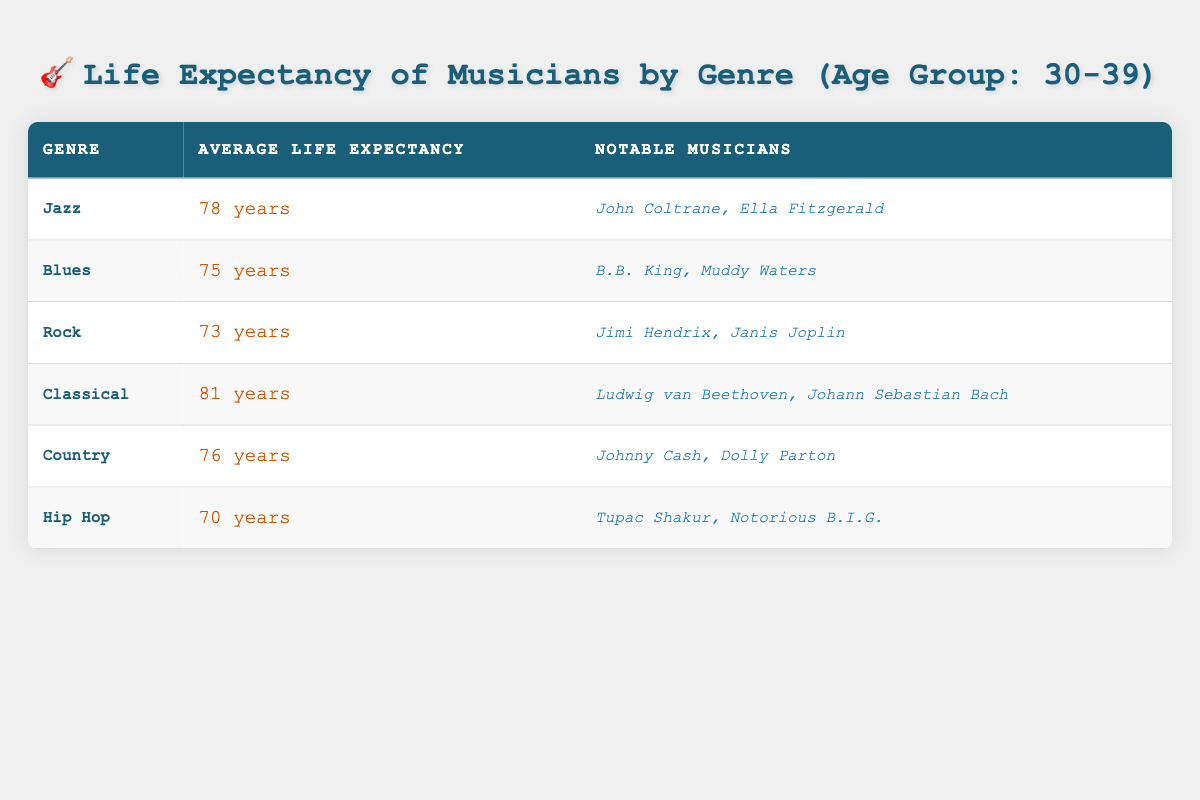What is the average life expectancy of Jazz musicians in the 30-39 age group? The table lists Jazz musicians with an average life expectancy of 78 years.
Answer: 78 years Who are the notable musicians from the Blues genre? The Blues genre features notable musicians B.B. King and Muddy Waters according to the table.
Answer: B.B. King, Muddy Waters Which genre has the highest average life expectancy for musicians aged 30-39? The table shows that Classical music has the highest average life expectancy at 81 years.
Answer: Classical What is the difference in life expectancy between Classical and Rock musicians? Classical musicians have an average life expectancy of 81 years, while Rock musicians have 73 years. The difference is 81 - 73 = 8 years.
Answer: 8 years Is the average life expectancy of Hip Hop musicians higher than Blues musicians? Hip Hop musicians have an average life expectancy of 70 years, while Blues musicians have 75 years. Therefore, it is false that Hip Hop musicians have a higher life expectancy.
Answer: No Which genres of musicians have an average life expectancy of 75 years or more? The genres with an average life expectancy of 75 years or more are Jazz (78), Blues (75), and Classical (81).
Answer: Jazz, Blues, Classical What is the average life expectancy of all the genres listed in the table? Adding all average life expectancies: 78 (Jazz) + 75 (Blues) + 73 (Rock) + 81 (Classical) + 76 (Country) + 70 (Hip Hop) = 453 years. Dividing by 6 gives an average of 75.5 years.
Answer: 75.5 years Do any genres have the same average life expectancy? Yes, both Blues and Country genres have the same life expectancy of 75 years.
Answer: Yes Which demographic group has the lowest average life expectancy among the listed genres? The Hip Hop genre has the lowest average life expectancy at 70 years, according to the table.
Answer: Hip Hop 